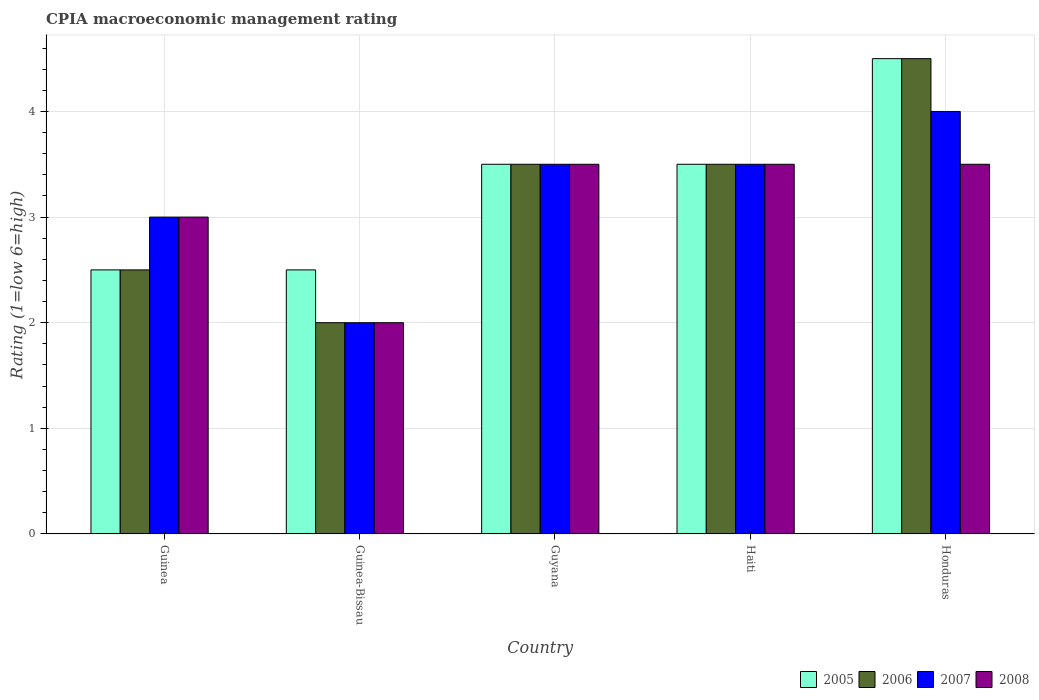How many groups of bars are there?
Your answer should be very brief. 5. Are the number of bars per tick equal to the number of legend labels?
Give a very brief answer. Yes. How many bars are there on the 5th tick from the left?
Your response must be concise. 4. What is the label of the 1st group of bars from the left?
Make the answer very short. Guinea. In how many cases, is the number of bars for a given country not equal to the number of legend labels?
Ensure brevity in your answer.  0. What is the CPIA rating in 2008 in Guyana?
Give a very brief answer. 3.5. Across all countries, what is the minimum CPIA rating in 2008?
Provide a succinct answer. 2. In which country was the CPIA rating in 2007 maximum?
Provide a short and direct response. Honduras. In which country was the CPIA rating in 2007 minimum?
Keep it short and to the point. Guinea-Bissau. What is the total CPIA rating in 2008 in the graph?
Your response must be concise. 15.5. In how many countries, is the CPIA rating in 2006 greater than 3.8?
Offer a terse response. 1. What is the ratio of the CPIA rating in 2005 in Guinea-Bissau to that in Guyana?
Offer a terse response. 0.71. Is the difference between the CPIA rating in 2008 in Haiti and Honduras greater than the difference between the CPIA rating in 2007 in Haiti and Honduras?
Offer a terse response. Yes. What is the difference between the highest and the second highest CPIA rating in 2007?
Your answer should be very brief. -0.5. In how many countries, is the CPIA rating in 2008 greater than the average CPIA rating in 2008 taken over all countries?
Provide a short and direct response. 3. Is the sum of the CPIA rating in 2005 in Guinea and Haiti greater than the maximum CPIA rating in 2006 across all countries?
Make the answer very short. Yes. What does the 1st bar from the left in Honduras represents?
Your answer should be compact. 2005. What does the 3rd bar from the right in Guinea represents?
Your response must be concise. 2006. Is it the case that in every country, the sum of the CPIA rating in 2005 and CPIA rating in 2007 is greater than the CPIA rating in 2006?
Ensure brevity in your answer.  Yes. How many bars are there?
Provide a short and direct response. 20. Are all the bars in the graph horizontal?
Ensure brevity in your answer.  No. How many countries are there in the graph?
Give a very brief answer. 5. What is the difference between two consecutive major ticks on the Y-axis?
Provide a short and direct response. 1. Are the values on the major ticks of Y-axis written in scientific E-notation?
Keep it short and to the point. No. How many legend labels are there?
Offer a terse response. 4. What is the title of the graph?
Provide a succinct answer. CPIA macroeconomic management rating. What is the label or title of the X-axis?
Keep it short and to the point. Country. What is the label or title of the Y-axis?
Give a very brief answer. Rating (1=low 6=high). What is the Rating (1=low 6=high) of 2008 in Guinea?
Offer a terse response. 3. What is the Rating (1=low 6=high) of 2005 in Guinea-Bissau?
Your answer should be compact. 2.5. What is the Rating (1=low 6=high) of 2006 in Guinea-Bissau?
Provide a short and direct response. 2. What is the Rating (1=low 6=high) of 2007 in Guinea-Bissau?
Offer a very short reply. 2. What is the Rating (1=low 6=high) of 2007 in Guyana?
Make the answer very short. 3.5. What is the Rating (1=low 6=high) in 2008 in Guyana?
Offer a very short reply. 3.5. What is the Rating (1=low 6=high) in 2005 in Haiti?
Your response must be concise. 3.5. What is the Rating (1=low 6=high) of 2006 in Haiti?
Your response must be concise. 3.5. What is the Rating (1=low 6=high) of 2007 in Haiti?
Offer a terse response. 3.5. What is the Rating (1=low 6=high) in 2007 in Honduras?
Give a very brief answer. 4. Across all countries, what is the maximum Rating (1=low 6=high) of 2008?
Your answer should be compact. 3.5. Across all countries, what is the minimum Rating (1=low 6=high) in 2005?
Ensure brevity in your answer.  2.5. Across all countries, what is the minimum Rating (1=low 6=high) in 2006?
Your answer should be compact. 2. What is the total Rating (1=low 6=high) in 2005 in the graph?
Your answer should be compact. 16.5. What is the total Rating (1=low 6=high) in 2006 in the graph?
Offer a very short reply. 16. What is the difference between the Rating (1=low 6=high) in 2005 in Guinea and that in Guinea-Bissau?
Provide a short and direct response. 0. What is the difference between the Rating (1=low 6=high) of 2006 in Guinea and that in Guinea-Bissau?
Make the answer very short. 0.5. What is the difference between the Rating (1=low 6=high) of 2007 in Guinea and that in Guinea-Bissau?
Provide a short and direct response. 1. What is the difference between the Rating (1=low 6=high) of 2008 in Guinea and that in Guinea-Bissau?
Provide a short and direct response. 1. What is the difference between the Rating (1=low 6=high) in 2006 in Guinea and that in Guyana?
Keep it short and to the point. -1. What is the difference between the Rating (1=low 6=high) of 2008 in Guinea and that in Guyana?
Offer a very short reply. -0.5. What is the difference between the Rating (1=low 6=high) of 2005 in Guinea and that in Haiti?
Your answer should be compact. -1. What is the difference between the Rating (1=low 6=high) of 2006 in Guinea and that in Haiti?
Make the answer very short. -1. What is the difference between the Rating (1=low 6=high) of 2008 in Guinea and that in Haiti?
Offer a terse response. -0.5. What is the difference between the Rating (1=low 6=high) of 2005 in Guinea and that in Honduras?
Your answer should be very brief. -2. What is the difference between the Rating (1=low 6=high) of 2008 in Guinea and that in Honduras?
Your answer should be compact. -0.5. What is the difference between the Rating (1=low 6=high) of 2005 in Guinea-Bissau and that in Guyana?
Provide a short and direct response. -1. What is the difference between the Rating (1=low 6=high) of 2006 in Guinea-Bissau and that in Guyana?
Keep it short and to the point. -1.5. What is the difference between the Rating (1=low 6=high) in 2008 in Guinea-Bissau and that in Guyana?
Give a very brief answer. -1.5. What is the difference between the Rating (1=low 6=high) in 2006 in Guinea-Bissau and that in Haiti?
Provide a succinct answer. -1.5. What is the difference between the Rating (1=low 6=high) in 2005 in Guinea-Bissau and that in Honduras?
Keep it short and to the point. -2. What is the difference between the Rating (1=low 6=high) in 2006 in Guinea-Bissau and that in Honduras?
Offer a very short reply. -2.5. What is the difference between the Rating (1=low 6=high) of 2005 in Guyana and that in Haiti?
Ensure brevity in your answer.  0. What is the difference between the Rating (1=low 6=high) of 2007 in Guyana and that in Haiti?
Provide a short and direct response. 0. What is the difference between the Rating (1=low 6=high) of 2008 in Guyana and that in Haiti?
Offer a very short reply. 0. What is the difference between the Rating (1=low 6=high) of 2005 in Guyana and that in Honduras?
Offer a very short reply. -1. What is the difference between the Rating (1=low 6=high) in 2006 in Guyana and that in Honduras?
Provide a short and direct response. -1. What is the difference between the Rating (1=low 6=high) of 2008 in Guyana and that in Honduras?
Your answer should be very brief. 0. What is the difference between the Rating (1=low 6=high) in 2005 in Haiti and that in Honduras?
Offer a terse response. -1. What is the difference between the Rating (1=low 6=high) in 2006 in Haiti and that in Honduras?
Your response must be concise. -1. What is the difference between the Rating (1=low 6=high) of 2007 in Haiti and that in Honduras?
Provide a succinct answer. -0.5. What is the difference between the Rating (1=low 6=high) of 2005 in Guinea and the Rating (1=low 6=high) of 2007 in Guinea-Bissau?
Keep it short and to the point. 0.5. What is the difference between the Rating (1=low 6=high) in 2005 in Guinea and the Rating (1=low 6=high) in 2008 in Guinea-Bissau?
Ensure brevity in your answer.  0.5. What is the difference between the Rating (1=low 6=high) of 2006 in Guinea and the Rating (1=low 6=high) of 2007 in Guinea-Bissau?
Provide a succinct answer. 0.5. What is the difference between the Rating (1=low 6=high) of 2005 in Guinea and the Rating (1=low 6=high) of 2006 in Guyana?
Your response must be concise. -1. What is the difference between the Rating (1=low 6=high) of 2006 in Guinea and the Rating (1=low 6=high) of 2007 in Guyana?
Ensure brevity in your answer.  -1. What is the difference between the Rating (1=low 6=high) in 2005 in Guinea and the Rating (1=low 6=high) in 2006 in Haiti?
Give a very brief answer. -1. What is the difference between the Rating (1=low 6=high) in 2006 in Guinea and the Rating (1=low 6=high) in 2007 in Haiti?
Keep it short and to the point. -1. What is the difference between the Rating (1=low 6=high) of 2005 in Guinea and the Rating (1=low 6=high) of 2007 in Honduras?
Provide a succinct answer. -1.5. What is the difference between the Rating (1=low 6=high) in 2005 in Guinea and the Rating (1=low 6=high) in 2008 in Honduras?
Offer a terse response. -1. What is the difference between the Rating (1=low 6=high) in 2006 in Guinea and the Rating (1=low 6=high) in 2007 in Honduras?
Offer a terse response. -1.5. What is the difference between the Rating (1=low 6=high) of 2007 in Guinea and the Rating (1=low 6=high) of 2008 in Honduras?
Keep it short and to the point. -0.5. What is the difference between the Rating (1=low 6=high) in 2005 in Guinea-Bissau and the Rating (1=low 6=high) in 2006 in Guyana?
Give a very brief answer. -1. What is the difference between the Rating (1=low 6=high) in 2005 in Guinea-Bissau and the Rating (1=low 6=high) in 2007 in Guyana?
Your answer should be compact. -1. What is the difference between the Rating (1=low 6=high) in 2006 in Guinea-Bissau and the Rating (1=low 6=high) in 2008 in Guyana?
Provide a succinct answer. -1.5. What is the difference between the Rating (1=low 6=high) in 2005 in Guinea-Bissau and the Rating (1=low 6=high) in 2006 in Haiti?
Offer a very short reply. -1. What is the difference between the Rating (1=low 6=high) in 2005 in Guinea-Bissau and the Rating (1=low 6=high) in 2007 in Haiti?
Provide a short and direct response. -1. What is the difference between the Rating (1=low 6=high) in 2005 in Guinea-Bissau and the Rating (1=low 6=high) in 2008 in Haiti?
Give a very brief answer. -1. What is the difference between the Rating (1=low 6=high) of 2007 in Guinea-Bissau and the Rating (1=low 6=high) of 2008 in Haiti?
Offer a terse response. -1.5. What is the difference between the Rating (1=low 6=high) of 2005 in Guinea-Bissau and the Rating (1=low 6=high) of 2006 in Honduras?
Your response must be concise. -2. What is the difference between the Rating (1=low 6=high) in 2006 in Guinea-Bissau and the Rating (1=low 6=high) in 2007 in Honduras?
Your answer should be very brief. -2. What is the difference between the Rating (1=low 6=high) in 2005 in Guyana and the Rating (1=low 6=high) in 2007 in Haiti?
Your response must be concise. 0. What is the difference between the Rating (1=low 6=high) of 2005 in Guyana and the Rating (1=low 6=high) of 2008 in Haiti?
Make the answer very short. 0. What is the difference between the Rating (1=low 6=high) in 2007 in Guyana and the Rating (1=low 6=high) in 2008 in Haiti?
Provide a succinct answer. 0. What is the difference between the Rating (1=low 6=high) in 2005 in Guyana and the Rating (1=low 6=high) in 2006 in Honduras?
Give a very brief answer. -1. What is the difference between the Rating (1=low 6=high) of 2005 in Guyana and the Rating (1=low 6=high) of 2008 in Honduras?
Your response must be concise. 0. What is the difference between the Rating (1=low 6=high) in 2006 in Guyana and the Rating (1=low 6=high) in 2008 in Honduras?
Provide a succinct answer. 0. What is the difference between the Rating (1=low 6=high) of 2007 in Guyana and the Rating (1=low 6=high) of 2008 in Honduras?
Keep it short and to the point. 0. What is the difference between the Rating (1=low 6=high) of 2005 in Haiti and the Rating (1=low 6=high) of 2007 in Honduras?
Offer a terse response. -0.5. What is the difference between the Rating (1=low 6=high) in 2006 in Haiti and the Rating (1=low 6=high) in 2007 in Honduras?
Offer a terse response. -0.5. What is the average Rating (1=low 6=high) of 2007 per country?
Keep it short and to the point. 3.2. What is the average Rating (1=low 6=high) of 2008 per country?
Make the answer very short. 3.1. What is the difference between the Rating (1=low 6=high) of 2005 and Rating (1=low 6=high) of 2006 in Guinea?
Your response must be concise. 0. What is the difference between the Rating (1=low 6=high) in 2006 and Rating (1=low 6=high) in 2007 in Guinea?
Your answer should be compact. -0.5. What is the difference between the Rating (1=low 6=high) of 2006 and Rating (1=low 6=high) of 2008 in Guinea?
Your answer should be compact. -0.5. What is the difference between the Rating (1=low 6=high) in 2007 and Rating (1=low 6=high) in 2008 in Guinea?
Give a very brief answer. 0. What is the difference between the Rating (1=low 6=high) in 2005 and Rating (1=low 6=high) in 2007 in Guinea-Bissau?
Your answer should be very brief. 0.5. What is the difference between the Rating (1=low 6=high) of 2005 and Rating (1=low 6=high) of 2008 in Guinea-Bissau?
Your answer should be compact. 0.5. What is the difference between the Rating (1=low 6=high) of 2006 and Rating (1=low 6=high) of 2008 in Guinea-Bissau?
Provide a short and direct response. 0. What is the difference between the Rating (1=low 6=high) of 2007 and Rating (1=low 6=high) of 2008 in Guinea-Bissau?
Offer a very short reply. 0. What is the difference between the Rating (1=low 6=high) in 2005 and Rating (1=low 6=high) in 2006 in Guyana?
Ensure brevity in your answer.  0. What is the difference between the Rating (1=low 6=high) in 2005 and Rating (1=low 6=high) in 2007 in Guyana?
Make the answer very short. 0. What is the difference between the Rating (1=low 6=high) of 2006 and Rating (1=low 6=high) of 2007 in Guyana?
Make the answer very short. 0. What is the difference between the Rating (1=low 6=high) in 2007 and Rating (1=low 6=high) in 2008 in Guyana?
Keep it short and to the point. 0. What is the difference between the Rating (1=low 6=high) of 2005 and Rating (1=low 6=high) of 2007 in Haiti?
Offer a terse response. 0. What is the difference between the Rating (1=low 6=high) in 2005 and Rating (1=low 6=high) in 2006 in Honduras?
Give a very brief answer. 0. What is the ratio of the Rating (1=low 6=high) in 2005 in Guinea to that in Guyana?
Make the answer very short. 0.71. What is the ratio of the Rating (1=low 6=high) of 2007 in Guinea to that in Guyana?
Give a very brief answer. 0.86. What is the ratio of the Rating (1=low 6=high) in 2006 in Guinea to that in Haiti?
Offer a very short reply. 0.71. What is the ratio of the Rating (1=low 6=high) of 2007 in Guinea to that in Haiti?
Provide a succinct answer. 0.86. What is the ratio of the Rating (1=low 6=high) in 2008 in Guinea to that in Haiti?
Provide a short and direct response. 0.86. What is the ratio of the Rating (1=low 6=high) of 2005 in Guinea to that in Honduras?
Offer a terse response. 0.56. What is the ratio of the Rating (1=low 6=high) in 2006 in Guinea to that in Honduras?
Offer a terse response. 0.56. What is the ratio of the Rating (1=low 6=high) of 2007 in Guinea to that in Honduras?
Your response must be concise. 0.75. What is the ratio of the Rating (1=low 6=high) in 2008 in Guinea to that in Honduras?
Your response must be concise. 0.86. What is the ratio of the Rating (1=low 6=high) of 2005 in Guinea-Bissau to that in Guyana?
Give a very brief answer. 0.71. What is the ratio of the Rating (1=low 6=high) in 2006 in Guinea-Bissau to that in Guyana?
Your response must be concise. 0.57. What is the ratio of the Rating (1=low 6=high) of 2007 in Guinea-Bissau to that in Guyana?
Keep it short and to the point. 0.57. What is the ratio of the Rating (1=low 6=high) of 2008 in Guinea-Bissau to that in Guyana?
Ensure brevity in your answer.  0.57. What is the ratio of the Rating (1=low 6=high) of 2008 in Guinea-Bissau to that in Haiti?
Provide a short and direct response. 0.57. What is the ratio of the Rating (1=low 6=high) in 2005 in Guinea-Bissau to that in Honduras?
Ensure brevity in your answer.  0.56. What is the ratio of the Rating (1=low 6=high) in 2006 in Guinea-Bissau to that in Honduras?
Your answer should be very brief. 0.44. What is the ratio of the Rating (1=low 6=high) of 2007 in Guinea-Bissau to that in Honduras?
Your response must be concise. 0.5. What is the ratio of the Rating (1=low 6=high) of 2005 in Guyana to that in Haiti?
Make the answer very short. 1. What is the ratio of the Rating (1=low 6=high) in 2007 in Guyana to that in Haiti?
Ensure brevity in your answer.  1. What is the ratio of the Rating (1=low 6=high) in 2008 in Guyana to that in Haiti?
Keep it short and to the point. 1. What is the ratio of the Rating (1=low 6=high) in 2005 in Guyana to that in Honduras?
Keep it short and to the point. 0.78. What is the ratio of the Rating (1=low 6=high) of 2006 in Guyana to that in Honduras?
Provide a short and direct response. 0.78. What is the ratio of the Rating (1=low 6=high) in 2008 in Guyana to that in Honduras?
Make the answer very short. 1. What is the ratio of the Rating (1=low 6=high) in 2005 in Haiti to that in Honduras?
Provide a short and direct response. 0.78. What is the ratio of the Rating (1=low 6=high) of 2006 in Haiti to that in Honduras?
Offer a terse response. 0.78. What is the ratio of the Rating (1=low 6=high) in 2008 in Haiti to that in Honduras?
Your response must be concise. 1. What is the difference between the highest and the second highest Rating (1=low 6=high) in 2006?
Make the answer very short. 1. What is the difference between the highest and the second highest Rating (1=low 6=high) in 2007?
Give a very brief answer. 0.5. What is the difference between the highest and the second highest Rating (1=low 6=high) in 2008?
Make the answer very short. 0. What is the difference between the highest and the lowest Rating (1=low 6=high) of 2005?
Offer a terse response. 2. 